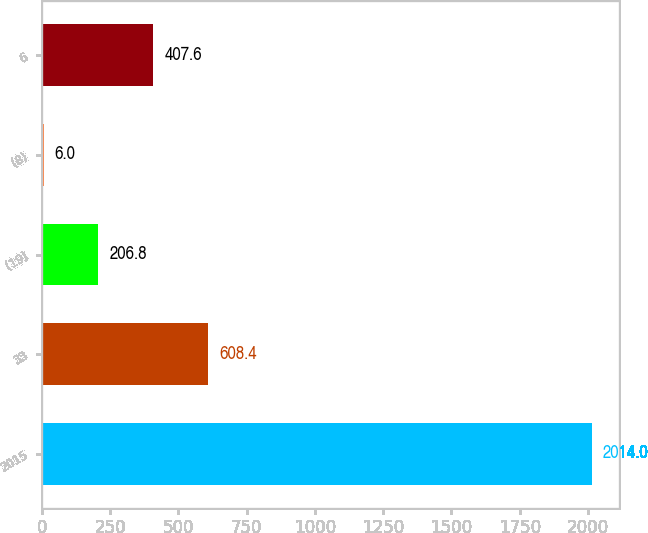<chart> <loc_0><loc_0><loc_500><loc_500><bar_chart><fcel>2015<fcel>33<fcel>(19)<fcel>(8)<fcel>6<nl><fcel>2014<fcel>608.4<fcel>206.8<fcel>6<fcel>407.6<nl></chart> 